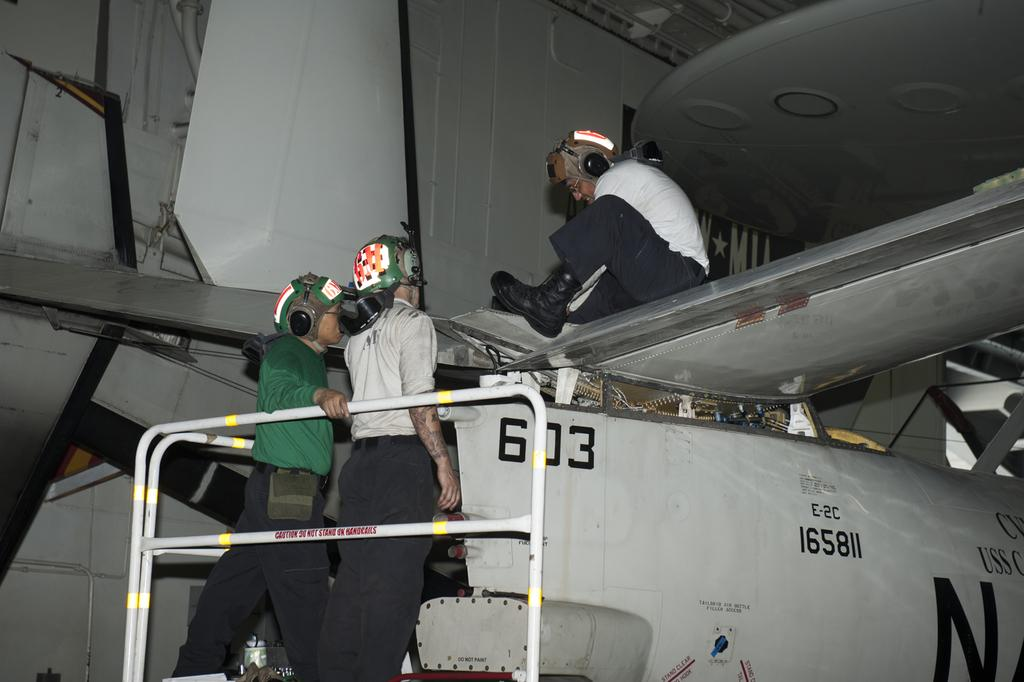How many people are present in the image? There are three people in the image. What is one person doing with their hands? One person is holding a rod. Can you describe the other elements in the image besides the people? There are objects, machines, and things in the image. What type of yoke is being used by the person holding the rod in the image? There is no yoke present in the image; the person is simply holding a rod. What type of authority is being exercised by the person holding the rod in the image? The image does not depict any authority being exercised; it only shows three people and a rod. 